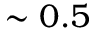Convert formula to latex. <formula><loc_0><loc_0><loc_500><loc_500>\sim 0 . 5</formula> 